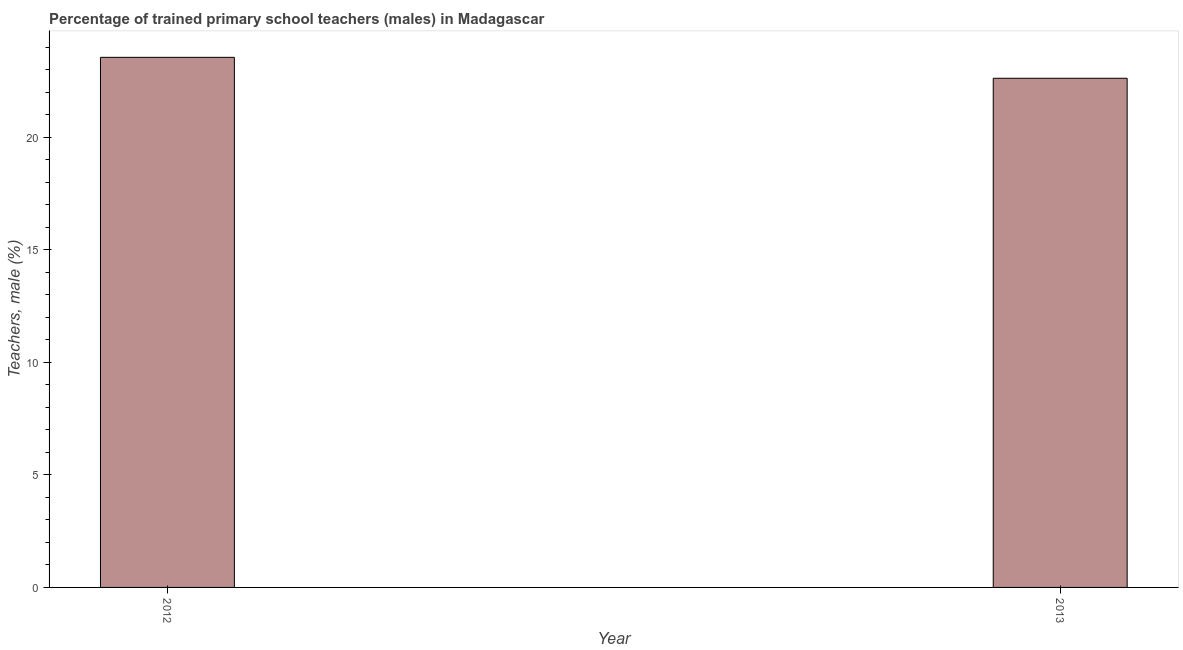What is the title of the graph?
Ensure brevity in your answer.  Percentage of trained primary school teachers (males) in Madagascar. What is the label or title of the Y-axis?
Provide a succinct answer. Teachers, male (%). What is the percentage of trained male teachers in 2013?
Your answer should be very brief. 22.62. Across all years, what is the maximum percentage of trained male teachers?
Provide a succinct answer. 23.55. Across all years, what is the minimum percentage of trained male teachers?
Give a very brief answer. 22.62. In which year was the percentage of trained male teachers minimum?
Offer a very short reply. 2013. What is the sum of the percentage of trained male teachers?
Your answer should be very brief. 46.16. What is the average percentage of trained male teachers per year?
Offer a terse response. 23.08. What is the median percentage of trained male teachers?
Your response must be concise. 23.08. In how many years, is the percentage of trained male teachers greater than 7 %?
Provide a succinct answer. 2. Do a majority of the years between 2013 and 2012 (inclusive) have percentage of trained male teachers greater than 20 %?
Provide a short and direct response. No. What is the ratio of the percentage of trained male teachers in 2012 to that in 2013?
Give a very brief answer. 1.04. Is the percentage of trained male teachers in 2012 less than that in 2013?
Your response must be concise. No. How many years are there in the graph?
Your answer should be very brief. 2. What is the Teachers, male (%) of 2012?
Provide a succinct answer. 23.55. What is the Teachers, male (%) of 2013?
Offer a terse response. 22.62. What is the difference between the Teachers, male (%) in 2012 and 2013?
Make the answer very short. 0.93. What is the ratio of the Teachers, male (%) in 2012 to that in 2013?
Keep it short and to the point. 1.04. 